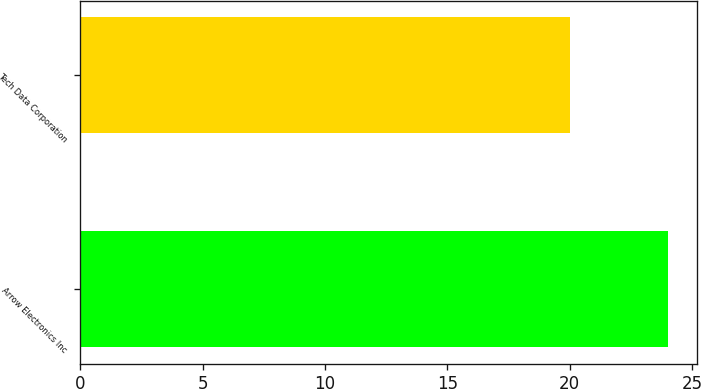<chart> <loc_0><loc_0><loc_500><loc_500><bar_chart><fcel>Arrow Electronics Inc<fcel>Tech Data Corporation<nl><fcel>24<fcel>20<nl></chart> 